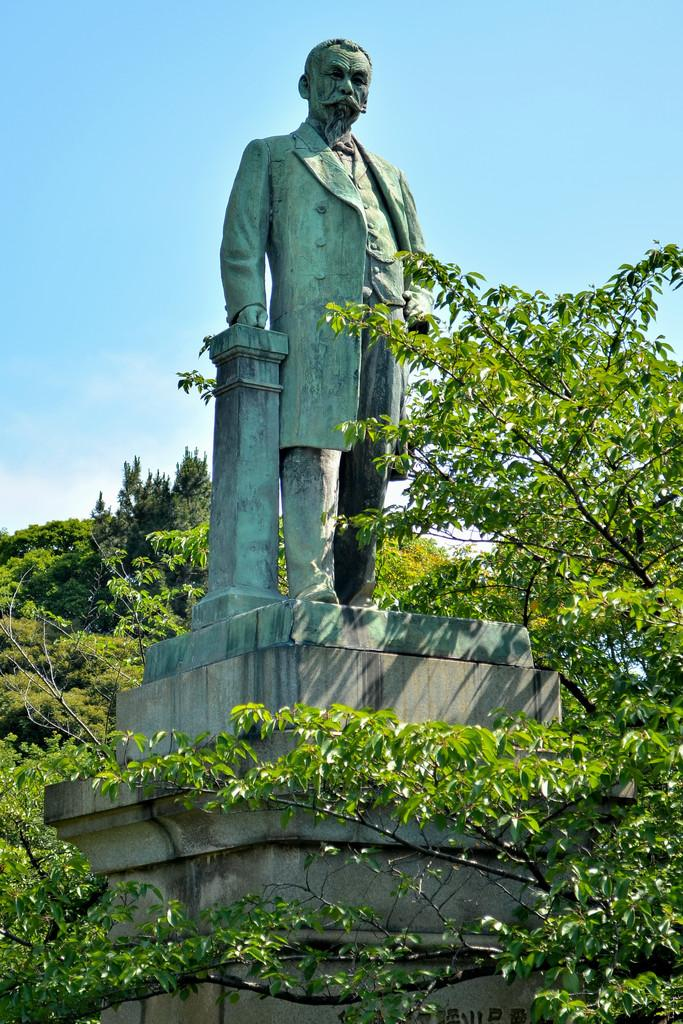What type of natural elements can be seen in the image? There are branches in the image. What is the main subject in the middle of the image? There is a statue in the middle of the image. What can be seen in the distance in the image? There is a sky visible in the background of the image. What type of yam is being harvested in the field in the image? There is no field or yam present in the image; it features branches and a statue. 